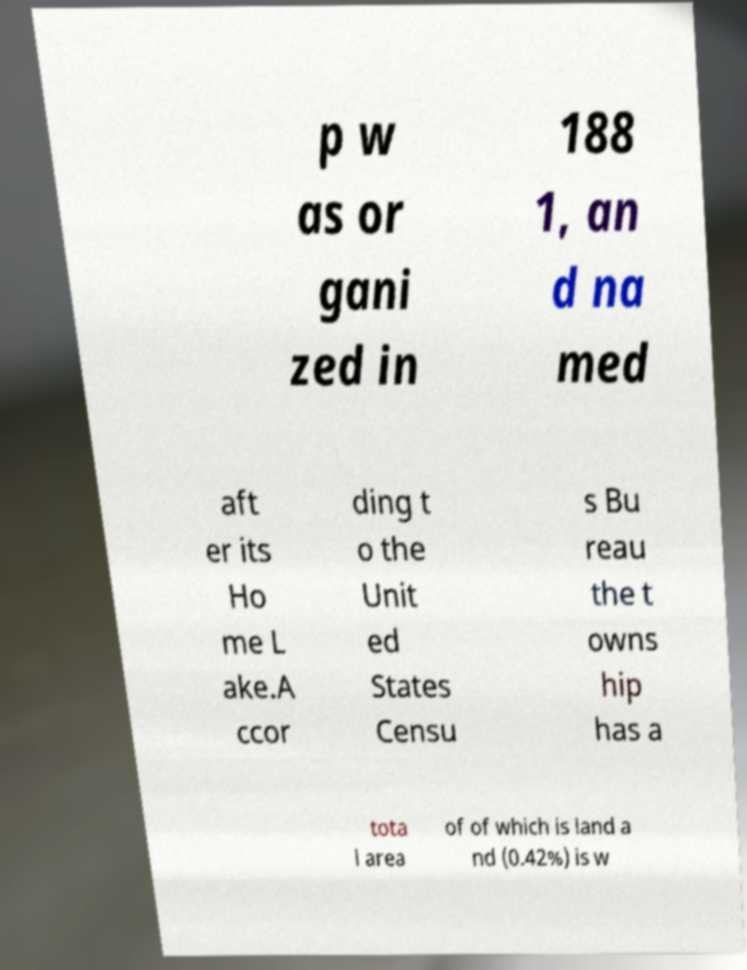Could you assist in decoding the text presented in this image and type it out clearly? p w as or gani zed in 188 1, an d na med aft er its Ho me L ake.A ccor ding t o the Unit ed States Censu s Bu reau the t owns hip has a tota l area of of which is land a nd (0.42%) is w 